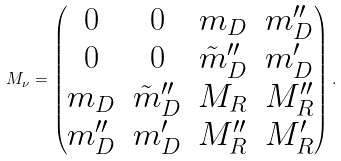Convert formula to latex. <formula><loc_0><loc_0><loc_500><loc_500>M _ { \nu } = \left ( \begin{matrix} 0 & 0 & m _ { D } & m _ { D } ^ { \prime \prime } \\ 0 & 0 & \tilde { m } _ { D } ^ { \prime \prime } & m ^ { \prime } _ { D } \\ m _ { D } & \tilde { m } _ { D } ^ { \prime \prime } & M _ { R } & M _ { R } ^ { \prime \prime } \\ m _ { D } ^ { \prime \prime } & m ^ { \prime } _ { D } & M _ { R } ^ { \prime \prime } & M _ { R } ^ { \prime } \end{matrix} \right ) .</formula> 